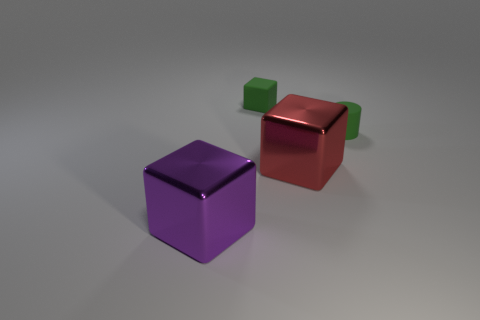Does the red object have the same material as the big purple object?
Your answer should be very brief. Yes. The other large object that is the same material as the big purple thing is what shape?
Your answer should be compact. Cube. Are there fewer big red objects than large brown metallic cubes?
Keep it short and to the point. No. There is a thing that is behind the big red metal block and to the left of the cylinder; what is its material?
Make the answer very short. Rubber. There is a shiny object left of the green thing to the left of the green cylinder behind the large red metallic thing; what size is it?
Your answer should be compact. Large. Is the shape of the large purple shiny thing the same as the small green thing in front of the green rubber cube?
Make the answer very short. No. How many things are in front of the green rubber block and behind the purple metal thing?
Make the answer very short. 2. What number of green things are either blocks or big objects?
Keep it short and to the point. 1. Does the metallic block that is in front of the large red object have the same color as the object behind the tiny green matte cylinder?
Give a very brief answer. No. What color is the cube to the right of the rubber thing behind the green matte thing on the right side of the red shiny block?
Offer a terse response. Red. 